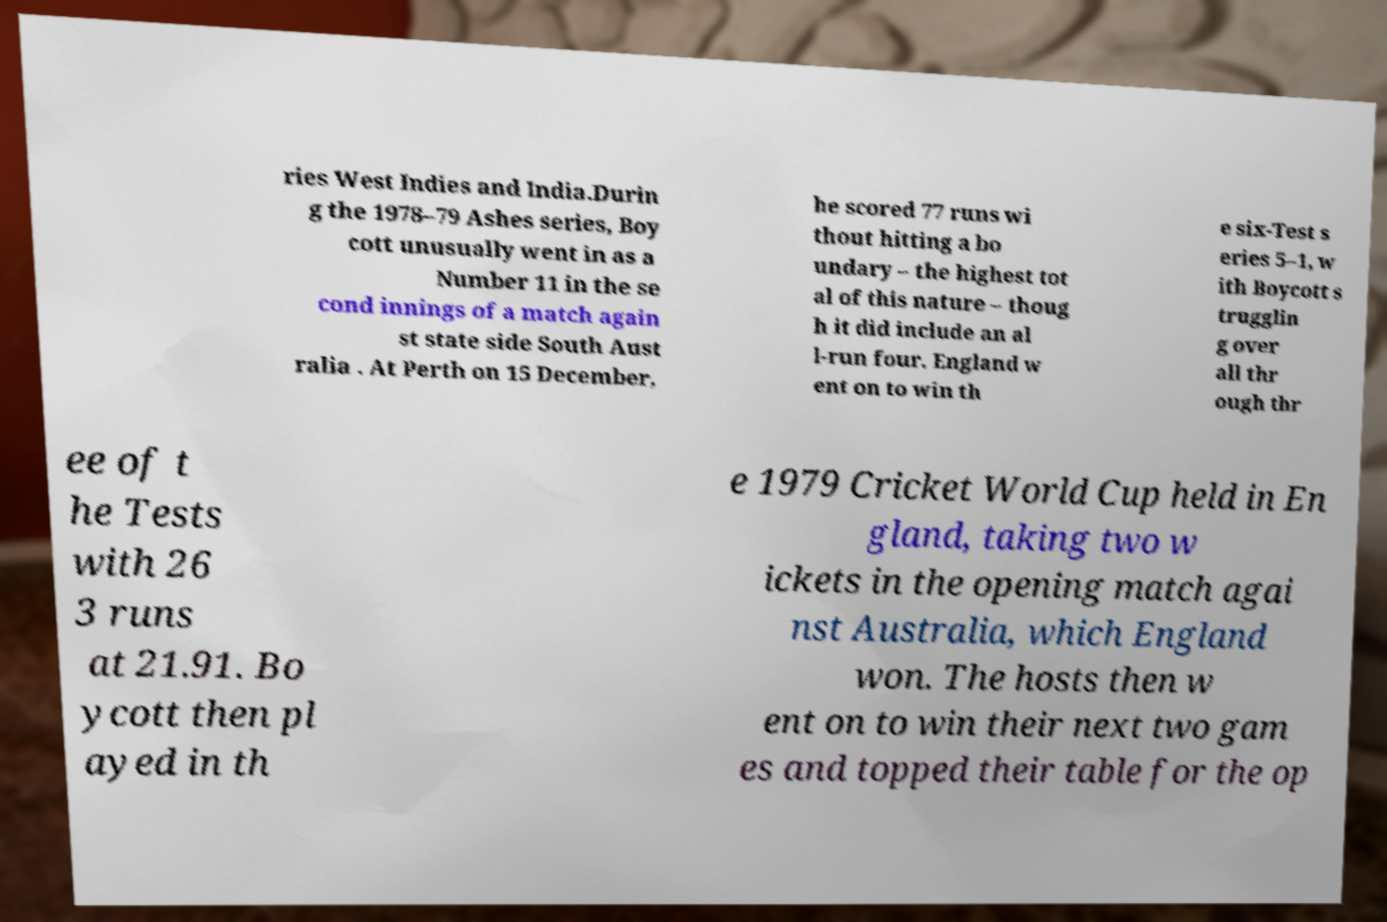Can you read and provide the text displayed in the image?This photo seems to have some interesting text. Can you extract and type it out for me? ries West Indies and India.Durin g the 1978–79 Ashes series, Boy cott unusually went in as a Number 11 in the se cond innings of a match again st state side South Aust ralia . At Perth on 15 December, he scored 77 runs wi thout hitting a bo undary – the highest tot al of this nature – thoug h it did include an al l-run four. England w ent on to win th e six-Test s eries 5–1, w ith Boycott s trugglin g over all thr ough thr ee of t he Tests with 26 3 runs at 21.91. Bo ycott then pl ayed in th e 1979 Cricket World Cup held in En gland, taking two w ickets in the opening match agai nst Australia, which England won. The hosts then w ent on to win their next two gam es and topped their table for the op 